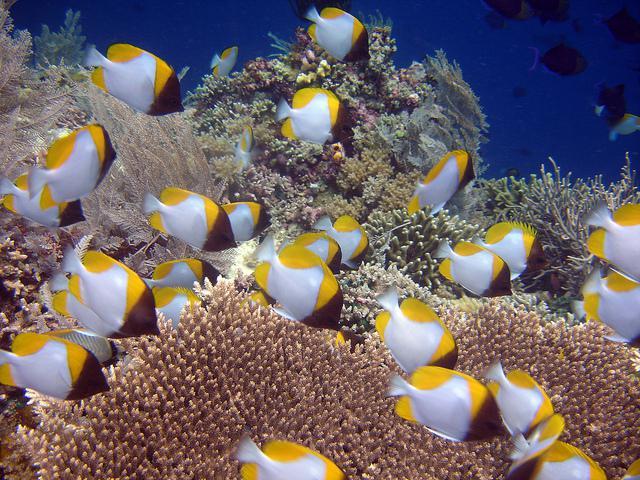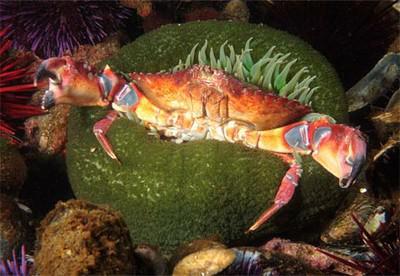The first image is the image on the left, the second image is the image on the right. Examine the images to the left and right. Is the description "There is a crab inside an anemone." accurate? Answer yes or no. Yes. The first image is the image on the left, the second image is the image on the right. Examine the images to the left and right. Is the description "An image shows multiple fish with yellow coloration swimming near a large anemone." accurate? Answer yes or no. Yes. 